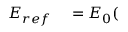Convert formula to latex. <formula><loc_0><loc_0><loc_500><loc_500>\begin{array} { r l } { E _ { r e f } } & = E _ { 0 } ( } \end{array}</formula> 